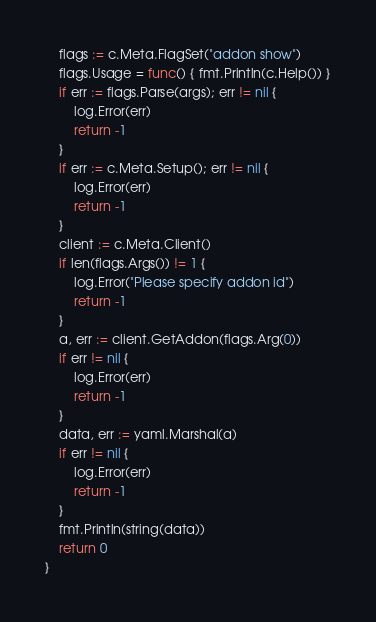<code> <loc_0><loc_0><loc_500><loc_500><_Go_>	flags := c.Meta.FlagSet("addon show")
	flags.Usage = func() { fmt.Println(c.Help()) }
	if err := flags.Parse(args); err != nil {
		log.Error(err)
		return -1
	}
	if err := c.Meta.Setup(); err != nil {
		log.Error(err)
		return -1
	}
	client := c.Meta.Client()
	if len(flags.Args()) != 1 {
		log.Error("Please specify addon id")
		return -1
	}
	a, err := client.GetAddon(flags.Arg(0))
	if err != nil {
		log.Error(err)
		return -1
	}
	data, err := yaml.Marshal(a)
	if err != nil {
		log.Error(err)
		return -1
	}
	fmt.Println(string(data))
	return 0
}
</code> 